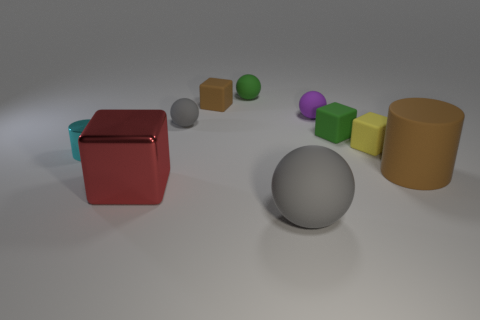What is the color of the big cube?
Ensure brevity in your answer.  Red. What number of big things are red shiny things or green spheres?
Your answer should be very brief. 1. Do the gray rubber sphere behind the big gray rubber ball and the gray matte object in front of the brown cylinder have the same size?
Your answer should be very brief. No. There is a green rubber thing that is the same shape as the tiny purple object; what is its size?
Keep it short and to the point. Small. Is the number of gray rubber things to the right of the tiny green block greater than the number of brown cylinders right of the rubber cylinder?
Your response must be concise. No. There is a thing that is both on the right side of the big gray object and in front of the yellow object; what is its material?
Offer a terse response. Rubber. What is the color of the big thing that is the same shape as the small yellow object?
Provide a succinct answer. Red. How big is the green ball?
Ensure brevity in your answer.  Small. There is a small ball that is on the right side of the gray matte ball in front of the small gray rubber object; what is its color?
Keep it short and to the point. Purple. How many cylinders are to the right of the tiny brown object and to the left of the red metallic cube?
Keep it short and to the point. 0. 